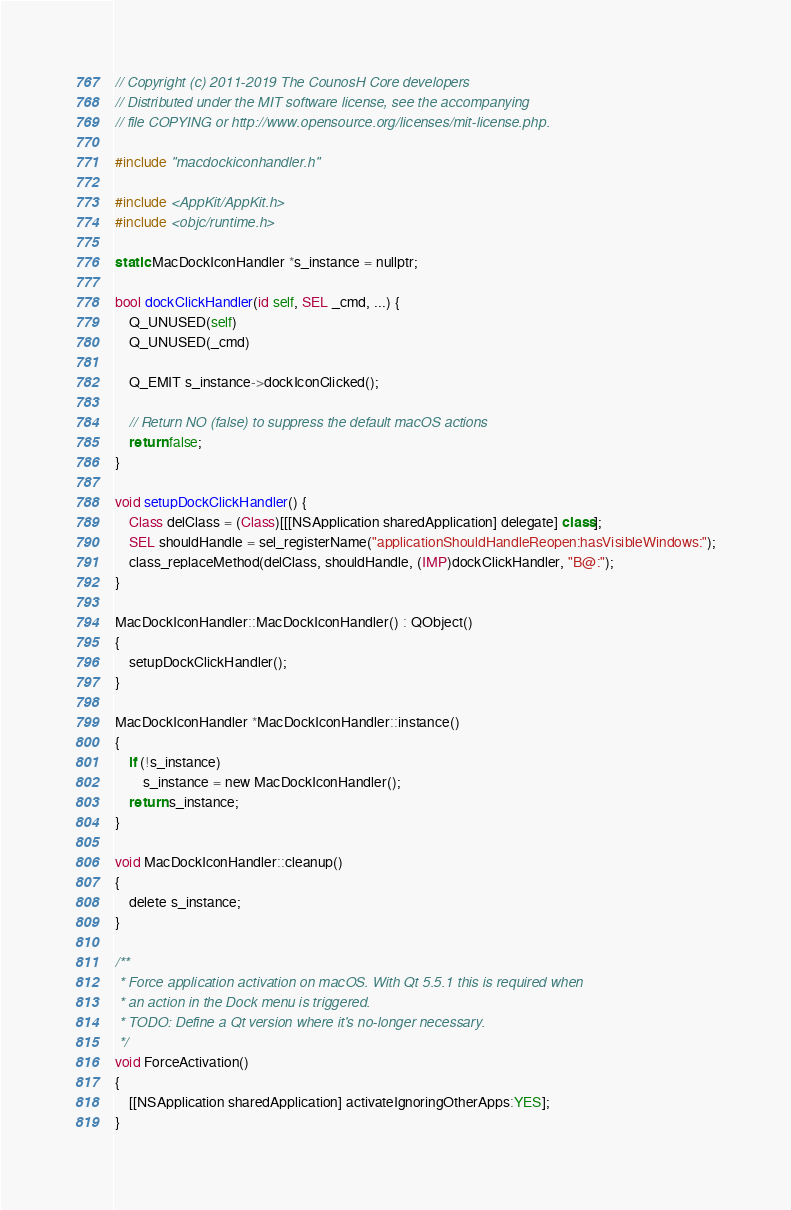Convert code to text. <code><loc_0><loc_0><loc_500><loc_500><_ObjectiveC_>// Copyright (c) 2011-2019 The CounosH Core developers
// Distributed under the MIT software license, see the accompanying
// file COPYING or http://www.opensource.org/licenses/mit-license.php.

#include "macdockiconhandler.h"

#include <AppKit/AppKit.h>
#include <objc/runtime.h>

static MacDockIconHandler *s_instance = nullptr;

bool dockClickHandler(id self, SEL _cmd, ...) {
    Q_UNUSED(self)
    Q_UNUSED(_cmd)

    Q_EMIT s_instance->dockIconClicked();

    // Return NO (false) to suppress the default macOS actions
    return false;
}

void setupDockClickHandler() {
    Class delClass = (Class)[[[NSApplication sharedApplication] delegate] class];
    SEL shouldHandle = sel_registerName("applicationShouldHandleReopen:hasVisibleWindows:");
    class_replaceMethod(delClass, shouldHandle, (IMP)dockClickHandler, "B@:");
}

MacDockIconHandler::MacDockIconHandler() : QObject()
{
    setupDockClickHandler();
}

MacDockIconHandler *MacDockIconHandler::instance()
{
    if (!s_instance)
        s_instance = new MacDockIconHandler();
    return s_instance;
}

void MacDockIconHandler::cleanup()
{
    delete s_instance;
}

/**
 * Force application activation on macOS. With Qt 5.5.1 this is required when
 * an action in the Dock menu is triggered.
 * TODO: Define a Qt version where it's no-longer necessary.
 */
void ForceActivation()
{
    [[NSApplication sharedApplication] activateIgnoringOtherApps:YES];
}
</code> 